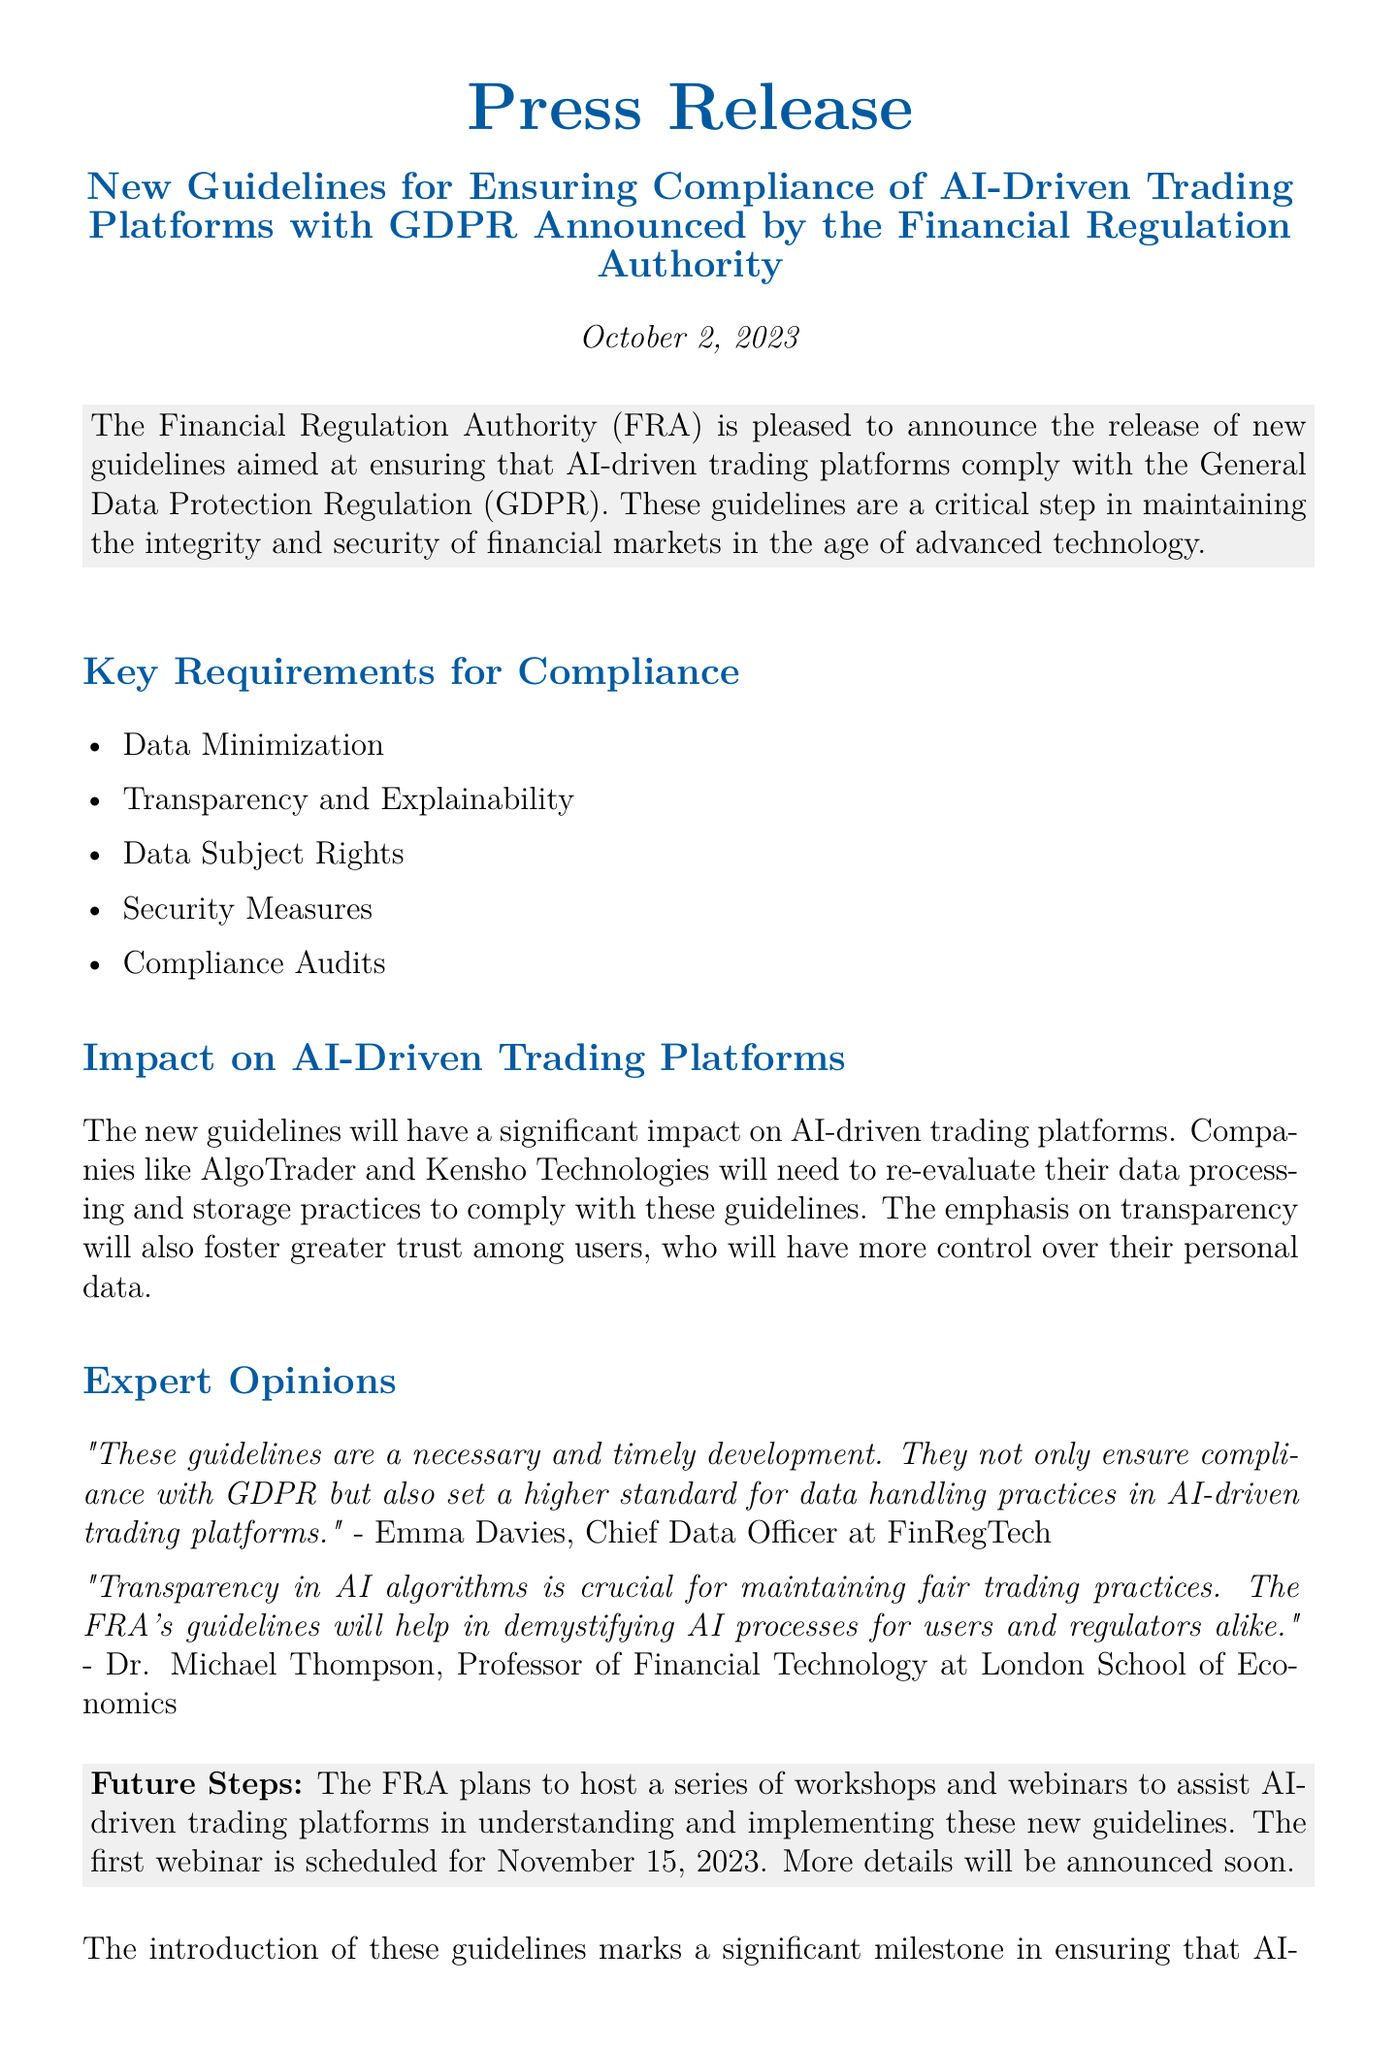What is the date of the press release? The date of the press release is mentioned at the top of the document.
Answer: October 2, 2023 Who is the Chief Data Officer at FinRegTech? The name of the Chief Data Officer is provided in the expert opinions section of the document.
Answer: Emma Davies What is one of the key requirements for compliance? The key requirements for compliance are listed under the "Key Requirements for Compliance" section.
Answer: Data Minimization What impact will the guidelines have on companies like AlgoTrader? The impact on AI-driven trading platforms is discussed in the relevant section of the document.
Answer: Re-evaluate data processing and storage practices When is the first webinar scheduled? The date of the first webinar is mentioned in the "Future Steps" section of the document.
Answer: November 15, 2023 What does the emphasis on transparency aim to foster? The document mentions what the emphasis on transparency will achieve in relation to users.
Answer: Greater trust What organization announced the new guidelines? The organization responsible for the announcement is stated at the beginning of the document.
Answer: Financial Regulation Authority What is the main purpose of the new guidelines? The purpose of the guidelines is summarized in the opening paragraph of the document.
Answer: Ensuring compliance with GDPR 